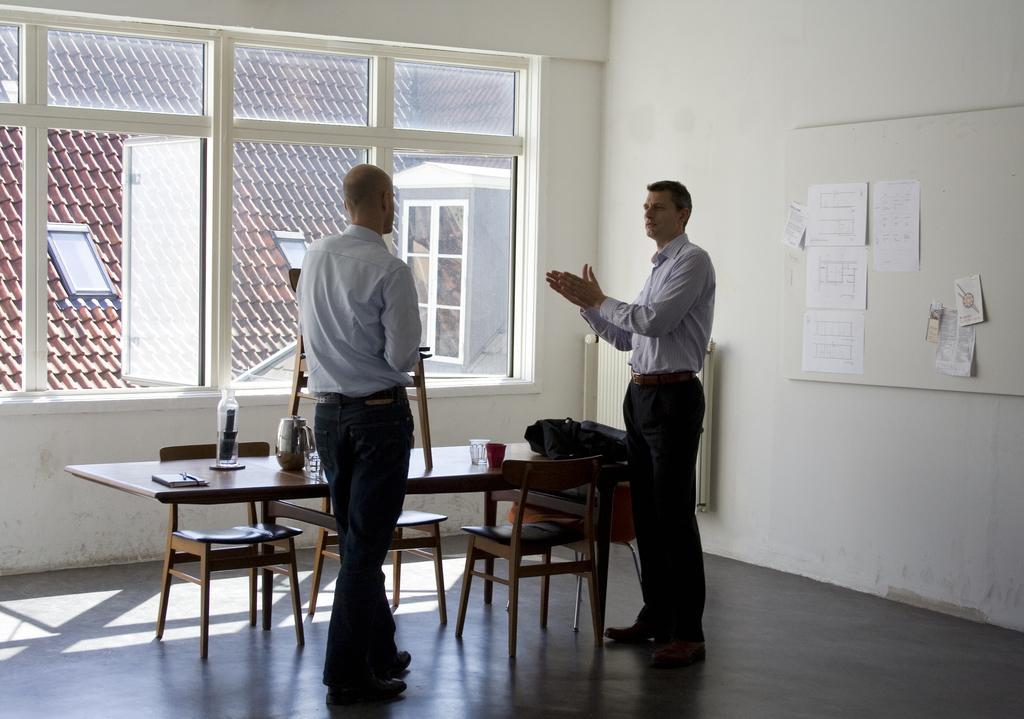In one or two sentences, can you explain what this image depicts? In this image I can see two men are standing, I can also see few chairs and a table. Here on this wall I can see few papers and here on this table I can see few glasses. 